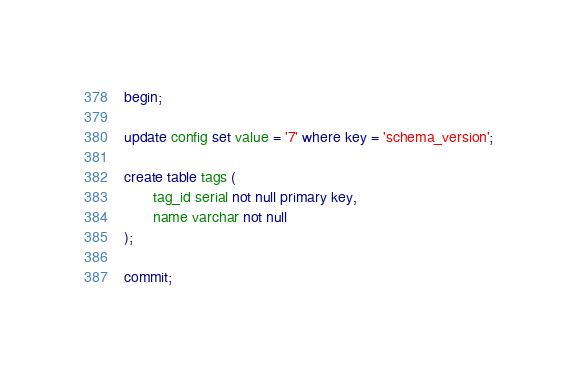Convert code to text. <code><loc_0><loc_0><loc_500><loc_500><_SQL_>begin;

update config set value = '7' where key = 'schema_version';

create table tags (
       tag_id serial not null primary key,
       name varchar not null
);

commit;
</code> 